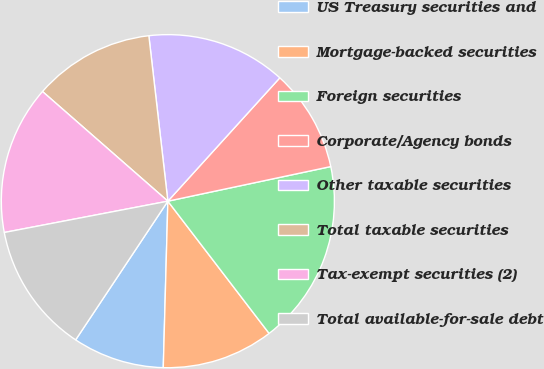Convert chart. <chart><loc_0><loc_0><loc_500><loc_500><pie_chart><fcel>US Treasury securities and<fcel>Mortgage-backed securities<fcel>Foreign securities<fcel>Corporate/Agency bonds<fcel>Other taxable securities<fcel>Total taxable securities<fcel>Tax-exempt securities (2)<fcel>Total available-for-sale debt<nl><fcel>8.9%<fcel>10.84%<fcel>17.93%<fcel>9.94%<fcel>13.55%<fcel>11.74%<fcel>14.45%<fcel>12.65%<nl></chart> 